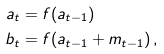Convert formula to latex. <formula><loc_0><loc_0><loc_500><loc_500>a _ { t } & = f ( a _ { t - 1 } ) \\ b _ { t } & = f ( a _ { t - 1 } + m _ { t - 1 } ) \, ,</formula> 